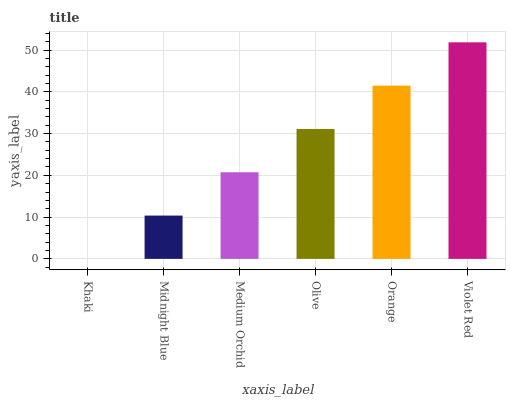Is Khaki the minimum?
Answer yes or no. Yes. Is Violet Red the maximum?
Answer yes or no. Yes. Is Midnight Blue the minimum?
Answer yes or no. No. Is Midnight Blue the maximum?
Answer yes or no. No. Is Midnight Blue greater than Khaki?
Answer yes or no. Yes. Is Khaki less than Midnight Blue?
Answer yes or no. Yes. Is Khaki greater than Midnight Blue?
Answer yes or no. No. Is Midnight Blue less than Khaki?
Answer yes or no. No. Is Olive the high median?
Answer yes or no. Yes. Is Medium Orchid the low median?
Answer yes or no. Yes. Is Orange the high median?
Answer yes or no. No. Is Khaki the low median?
Answer yes or no. No. 